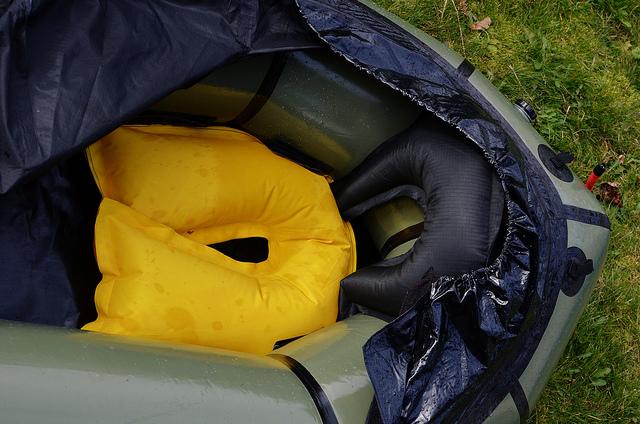Does the life raft float?
Short answer required. Yes. What is the yellow thing?
Quick response, please. Life vest. What type of boat is this?
Keep it brief. Raft. 